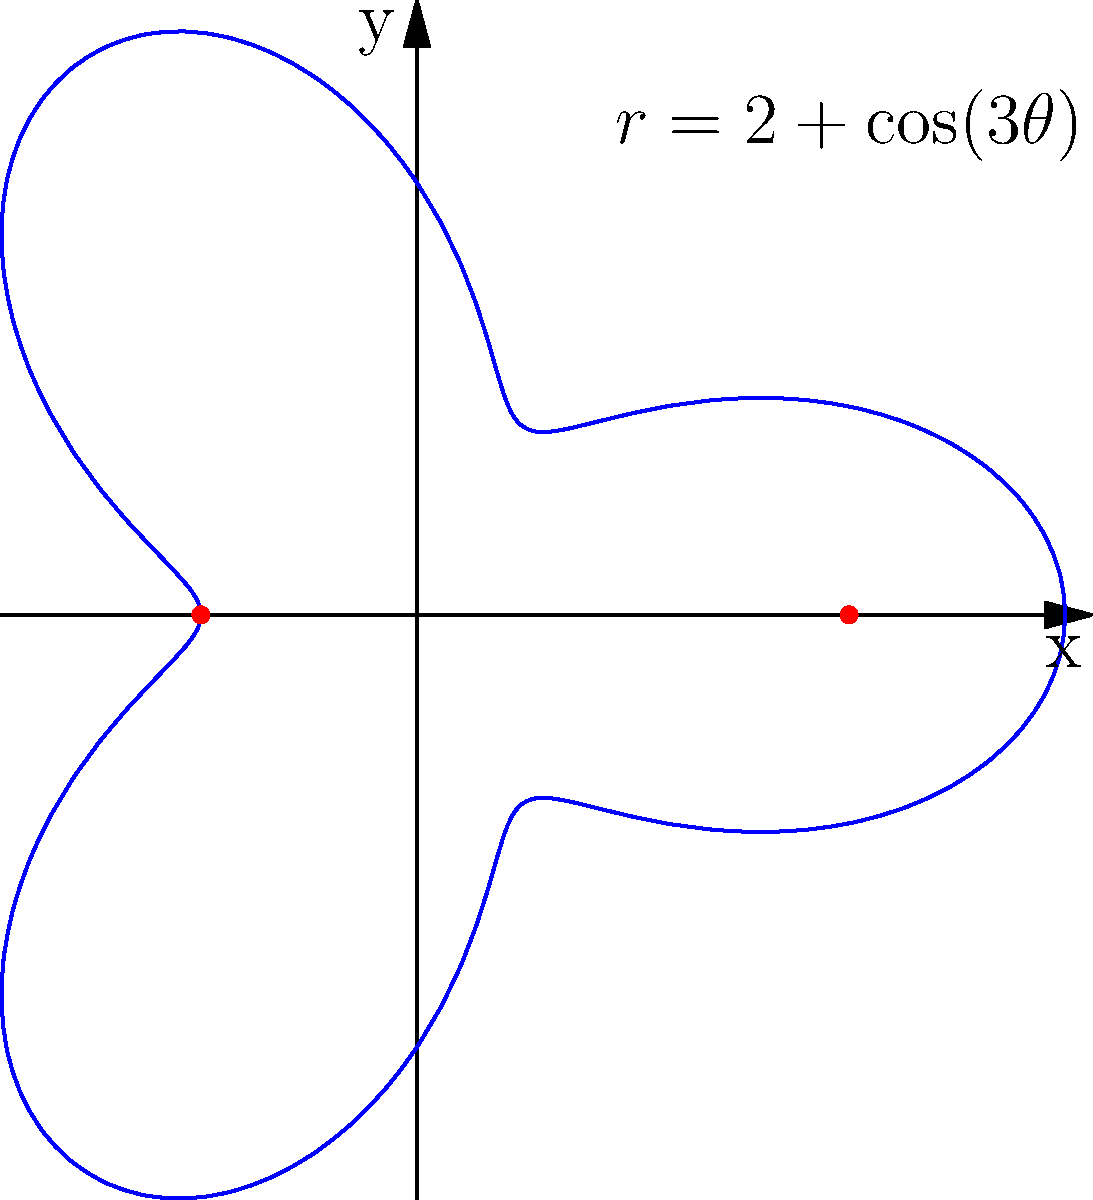As an expert archer, you're analyzing your shooting range represented by the polar equation $r=2+\cos(3\theta)$. Calculate the area covered by your shooting range within one complete revolution. Round your answer to two decimal places. To find the area covered by the polar curve $r=2+\cos(3\theta)$ over one complete revolution, we'll use the formula for area in polar coordinates:

$$ A = \frac{1}{2} \int_{0}^{2\pi} r^2 d\theta $$

Step 1: Substitute the given equation for $r$ into the formula.
$$ A = \frac{1}{2} \int_{0}^{2\pi} (2+\cos(3\theta))^2 d\theta $$

Step 2: Expand the squared term.
$$ A = \frac{1}{2} \int_{0}^{2\pi} (4 + 4\cos(3\theta) + \cos^2(3\theta)) d\theta $$

Step 3: Use the identity $\cos^2(x) = \frac{1}{2}(1 + \cos(2x))$.
$$ A = \frac{1}{2} \int_{0}^{2\pi} (4 + 4\cos(3\theta) + \frac{1}{2}(1 + \cos(6\theta))) d\theta $$

Step 4: Simplify and integrate.
$$ A = \frac{1}{2} \int_{0}^{2\pi} (4.5 + 4\cos(3\theta) + \frac{1}{2}\cos(6\theta)) d\theta $$
$$ A = \frac{1}{2} [4.5\theta + \frac{4}{3}\sin(3\theta) + \frac{1}{12}\sin(6\theta)]_{0}^{2\pi} $$

Step 5: Evaluate the integral.
$$ A = \frac{1}{2} [4.5(2\pi) + 0 + 0] $$
$$ A = \frac{1}{2} (9\pi) = \frac{9\pi}{2} $$

Step 6: Calculate the numerical value and round to two decimal places.
$$ A \approx 14.14 $$
Answer: 14.14 square units 